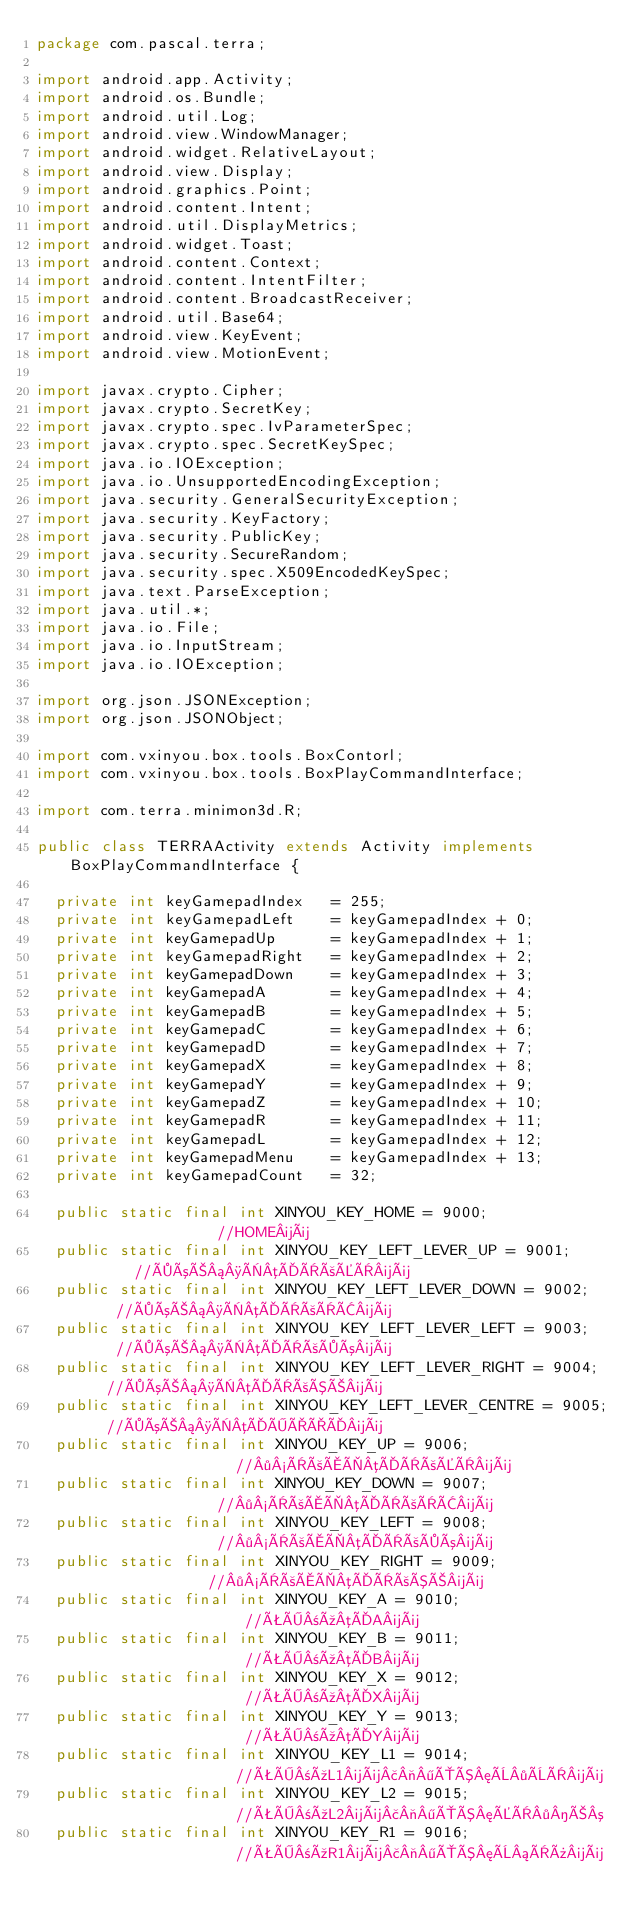<code> <loc_0><loc_0><loc_500><loc_500><_Java_>package com.pascal.terra;

import android.app.Activity;
import android.os.Bundle;
import android.util.Log;
import android.view.WindowManager;
import android.widget.RelativeLayout;
import android.view.Display;
import android.graphics.Point;
import android.content.Intent;
import android.util.DisplayMetrics;
import android.widget.Toast;
import android.content.Context;
import android.content.IntentFilter;
import android.content.BroadcastReceiver;
import android.util.Base64;
import android.view.KeyEvent;
import android.view.MotionEvent;

import javax.crypto.Cipher;
import javax.crypto.SecretKey;
import javax.crypto.spec.IvParameterSpec;
import javax.crypto.spec.SecretKeySpec;
import java.io.IOException;
import java.io.UnsupportedEncodingException;
import java.security.GeneralSecurityException;
import java.security.KeyFactory;
import java.security.PublicKey;
import java.security.SecureRandom;
import java.security.spec.X509EncodedKeySpec;
import java.text.ParseException;
import java.util.*;
import java.io.File;
import java.io.InputStream;
import java.io.IOException;

import org.json.JSONException;
import org.json.JSONObject;

import com.vxinyou.box.tools.BoxContorl;
import com.vxinyou.box.tools.BoxPlayCommandInterface;

import com.terra.minimon3d.R;

public class TERRAActivity extends Activity implements BoxPlayCommandInterface {

	private int keyGamepadIndex   = 255;
	private int keyGamepadLeft    = keyGamepadIndex + 0;
	private int keyGamepadUp      = keyGamepadIndex + 1;
	private int keyGamepadRight   = keyGamepadIndex + 2;
	private int keyGamepadDown    = keyGamepadIndex + 3;
	private int keyGamepadA       = keyGamepadIndex + 4;
	private int keyGamepadB       = keyGamepadIndex + 5;
	private int keyGamepadC       = keyGamepadIndex + 6;
	private int keyGamepadD       = keyGamepadIndex + 7;
	private int keyGamepadX       = keyGamepadIndex + 8;
	private int keyGamepadY       = keyGamepadIndex + 9;
	private int keyGamepadZ       = keyGamepadIndex + 10;
	private int keyGamepadR       = keyGamepadIndex + 11;
	private int keyGamepadL       = keyGamepadIndex + 12;
	private int keyGamepadMenu    = keyGamepadIndex + 13;
	private int keyGamepadCount   = 32;

	public static final int XINYOU_KEY_HOME = 9000;               //HOME¼ü
	public static final int XINYOU_KEY_LEFT_LEVER_UP = 9001;      //×óÒ¡¸ËµÄÏòÉÏ¼ü
	public static final int XINYOU_KEY_LEFT_LEVER_DOWN = 9002;    //×óÒ¡¸ËµÄÏòÏÂ¼ü
	public static final int XINYOU_KEY_LEFT_LEVER_LEFT = 9003;    //×óÒ¡¸ËµÄÏò×ó¼ü
	public static final int XINYOU_KEY_LEFT_LEVER_RIGHT = 9004;   //×óÒ¡¸ËµÄÏòÓÒ¼ü
	public static final int XINYOU_KEY_LEFT_LEVER_CENTRE = 9005;  //×óÒ¡¸ËµÄÖÐÐÄ¼ü
	public static final int XINYOU_KEY_UP = 9006;                 //·½ÏòÅÌµÄÏòÉÏ¼ü
	public static final int XINYOU_KEY_DOWN = 9007;               //·½ÏòÅÌµÄÏòÏÂ¼ü
	public static final int XINYOU_KEY_LEFT = 9008;               //·½ÏòÅÌµÄÏò×ó¼ü
	public static final int XINYOU_KEY_RIGHT = 9009;              //·½ÏòÅÌµÄÏòÓÒ¼ü
	public static final int XINYOU_KEY_A = 9010;                  //ÊÖ±úµÄA¼ü
	public static final int XINYOU_KEY_B = 9011;                  //ÊÖ±úµÄB¼ü
	public static final int XINYOU_KEY_X = 9012;                  //ÊÖ±úµÄX¼ü
	public static final int XINYOU_KEY_Y = 9013;                  //ÊÖ±úµÄY¼ü
	public static final int XINYOU_KEY_L1 = 9014;                 //ÊÖ±úL1¼ü£¬¶ÔÓ¦È·ÈÏ¼ü
	public static final int XINYOU_KEY_L2 = 9015;                 //ÊÖ±úL2¼ü£¬¶ÔÓ¦ÉÏ·­Ò³
	public static final int XINYOU_KEY_R1 = 9016;                 //ÊÖ±úR1¼ü£¬¶ÔÓ¦È¡Ïû¼ü</code> 